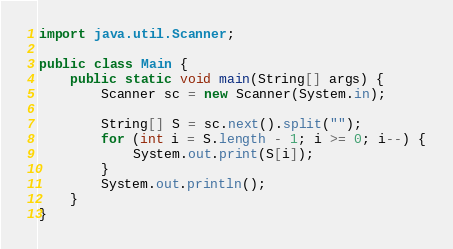<code> <loc_0><loc_0><loc_500><loc_500><_Java_>import java.util.Scanner;

public class Main {
    public static void main(String[] args) {
        Scanner sc = new Scanner(System.in);

        String[] S = sc.next().split("");
        for (int i = S.length - 1; i >= 0; i--) {
            System.out.print(S[i]);
        }
        System.out.println();
    }
}</code> 